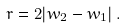<formula> <loc_0><loc_0><loc_500><loc_500>r = 2 | w _ { 2 } - w _ { 1 } | \, .</formula> 